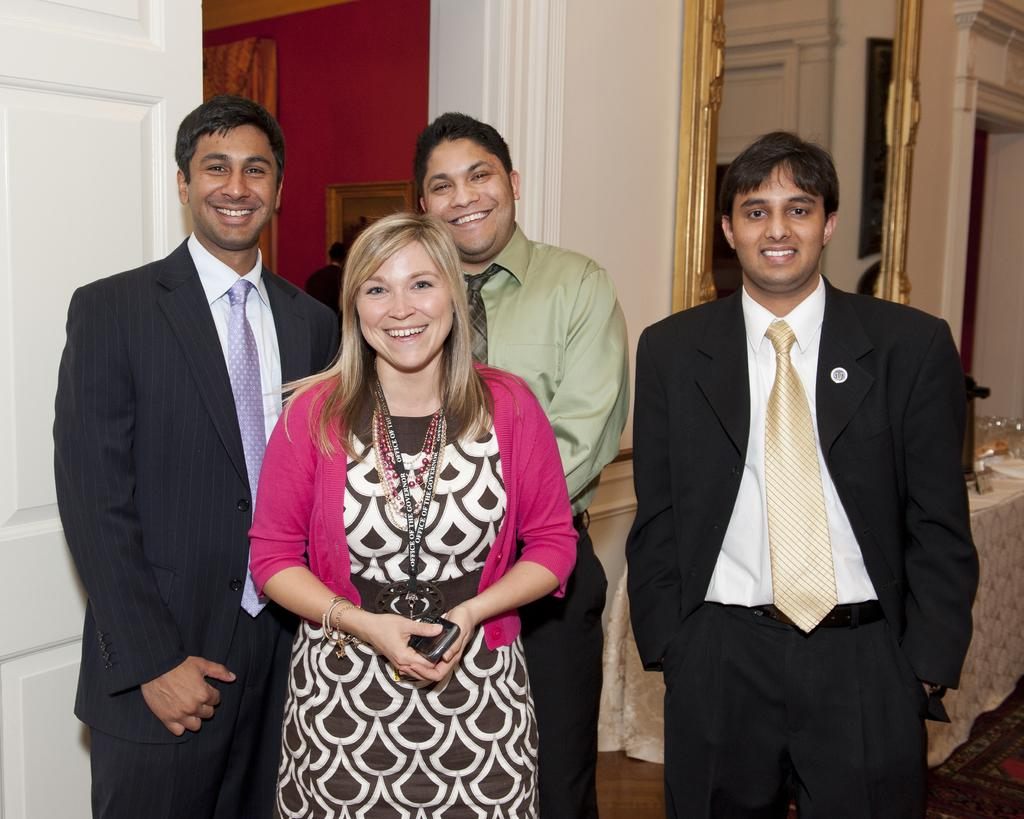How many people are in the foreground of the image? There are four persons standing in the foreground of the image. What can be seen in the background of the image? There is a wall, a mirror, a person, a table, and a door in the background of the image. What might be the location of the image based on the background elements? The image may have been taken in a hall, given the presence of a wall, table, and door. What type of rod can be seen holding up the cherry tree in the image? There is no cherry tree or rod present in the image. Can you recite a verse that is written on the wall in the image? There is no verse visible on the wall in the image. 